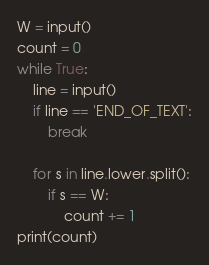<code> <loc_0><loc_0><loc_500><loc_500><_Python_>W = input()
count = 0
while True:
    line = input()
    if line == 'END_OF_TEXT':
        break

    for s in line.lower.split():
        if s == W:
            count += 1
print(count)</code> 